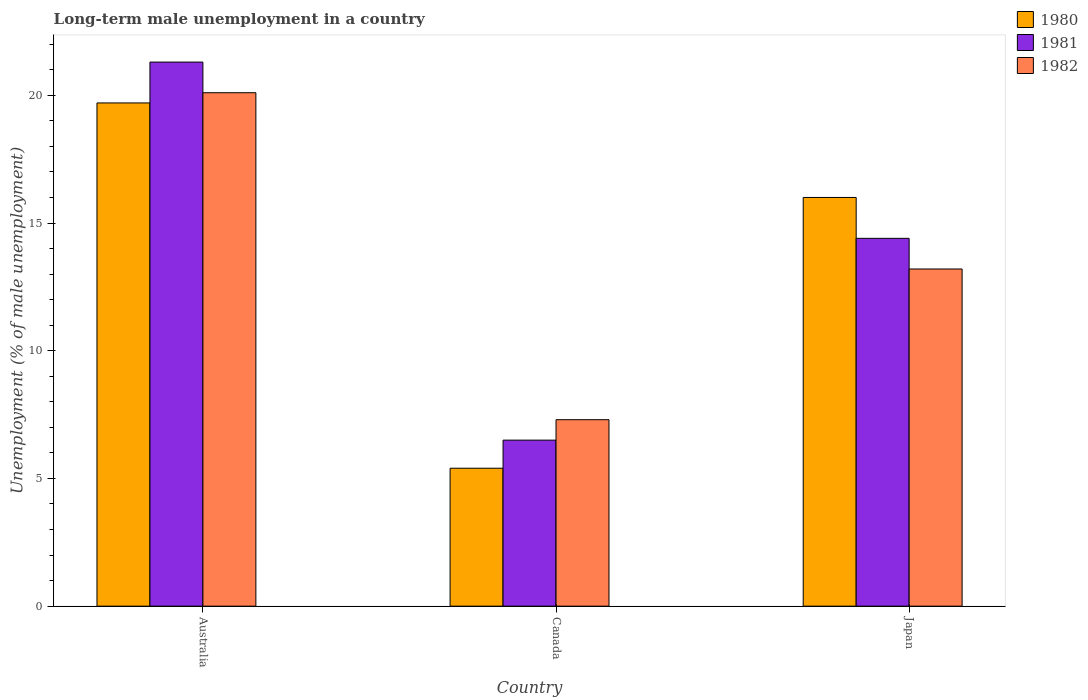How many different coloured bars are there?
Give a very brief answer. 3. Are the number of bars per tick equal to the number of legend labels?
Keep it short and to the point. Yes. How many bars are there on the 1st tick from the left?
Provide a succinct answer. 3. How many bars are there on the 3rd tick from the right?
Keep it short and to the point. 3. What is the percentage of long-term unemployed male population in 1980 in Canada?
Give a very brief answer. 5.4. Across all countries, what is the maximum percentage of long-term unemployed male population in 1981?
Your answer should be compact. 21.3. Across all countries, what is the minimum percentage of long-term unemployed male population in 1980?
Give a very brief answer. 5.4. What is the total percentage of long-term unemployed male population in 1980 in the graph?
Provide a short and direct response. 41.1. What is the difference between the percentage of long-term unemployed male population in 1980 in Canada and that in Japan?
Your answer should be compact. -10.6. What is the difference between the percentage of long-term unemployed male population in 1980 in Australia and the percentage of long-term unemployed male population in 1982 in Canada?
Your response must be concise. 12.4. What is the average percentage of long-term unemployed male population in 1981 per country?
Provide a short and direct response. 14.07. What is the difference between the percentage of long-term unemployed male population of/in 1982 and percentage of long-term unemployed male population of/in 1980 in Australia?
Your response must be concise. 0.4. In how many countries, is the percentage of long-term unemployed male population in 1980 greater than 9 %?
Make the answer very short. 2. What is the ratio of the percentage of long-term unemployed male population in 1982 in Canada to that in Japan?
Provide a short and direct response. 0.55. Is the percentage of long-term unemployed male population in 1980 in Canada less than that in Japan?
Provide a short and direct response. Yes. What is the difference between the highest and the second highest percentage of long-term unemployed male population in 1982?
Your response must be concise. 6.9. What is the difference between the highest and the lowest percentage of long-term unemployed male population in 1980?
Provide a succinct answer. 14.3. Is the sum of the percentage of long-term unemployed male population in 1980 in Australia and Japan greater than the maximum percentage of long-term unemployed male population in 1981 across all countries?
Offer a terse response. Yes. What does the 1st bar from the left in Canada represents?
Offer a terse response. 1980. Is it the case that in every country, the sum of the percentage of long-term unemployed male population in 1981 and percentage of long-term unemployed male population in 1982 is greater than the percentage of long-term unemployed male population in 1980?
Give a very brief answer. Yes. Are all the bars in the graph horizontal?
Keep it short and to the point. No. What is the difference between two consecutive major ticks on the Y-axis?
Provide a short and direct response. 5. Where does the legend appear in the graph?
Ensure brevity in your answer.  Top right. How many legend labels are there?
Give a very brief answer. 3. How are the legend labels stacked?
Your answer should be compact. Vertical. What is the title of the graph?
Your response must be concise. Long-term male unemployment in a country. What is the label or title of the X-axis?
Make the answer very short. Country. What is the label or title of the Y-axis?
Give a very brief answer. Unemployment (% of male unemployment). What is the Unemployment (% of male unemployment) in 1980 in Australia?
Offer a very short reply. 19.7. What is the Unemployment (% of male unemployment) of 1981 in Australia?
Offer a very short reply. 21.3. What is the Unemployment (% of male unemployment) in 1982 in Australia?
Your answer should be very brief. 20.1. What is the Unemployment (% of male unemployment) in 1980 in Canada?
Give a very brief answer. 5.4. What is the Unemployment (% of male unemployment) of 1982 in Canada?
Make the answer very short. 7.3. What is the Unemployment (% of male unemployment) of 1980 in Japan?
Your answer should be very brief. 16. What is the Unemployment (% of male unemployment) of 1981 in Japan?
Offer a terse response. 14.4. What is the Unemployment (% of male unemployment) of 1982 in Japan?
Your answer should be very brief. 13.2. Across all countries, what is the maximum Unemployment (% of male unemployment) of 1980?
Keep it short and to the point. 19.7. Across all countries, what is the maximum Unemployment (% of male unemployment) of 1981?
Provide a short and direct response. 21.3. Across all countries, what is the maximum Unemployment (% of male unemployment) in 1982?
Give a very brief answer. 20.1. Across all countries, what is the minimum Unemployment (% of male unemployment) in 1980?
Provide a short and direct response. 5.4. Across all countries, what is the minimum Unemployment (% of male unemployment) in 1982?
Offer a terse response. 7.3. What is the total Unemployment (% of male unemployment) in 1980 in the graph?
Keep it short and to the point. 41.1. What is the total Unemployment (% of male unemployment) in 1981 in the graph?
Ensure brevity in your answer.  42.2. What is the total Unemployment (% of male unemployment) in 1982 in the graph?
Provide a succinct answer. 40.6. What is the difference between the Unemployment (% of male unemployment) in 1981 in Australia and that in Canada?
Offer a terse response. 14.8. What is the difference between the Unemployment (% of male unemployment) of 1982 in Australia and that in Canada?
Make the answer very short. 12.8. What is the difference between the Unemployment (% of male unemployment) of 1980 in Australia and that in Japan?
Give a very brief answer. 3.7. What is the difference between the Unemployment (% of male unemployment) in 1982 in Australia and that in Japan?
Make the answer very short. 6.9. What is the difference between the Unemployment (% of male unemployment) in 1980 in Canada and that in Japan?
Offer a very short reply. -10.6. What is the difference between the Unemployment (% of male unemployment) of 1981 in Canada and that in Japan?
Provide a succinct answer. -7.9. What is the difference between the Unemployment (% of male unemployment) in 1980 in Australia and the Unemployment (% of male unemployment) in 1981 in Canada?
Make the answer very short. 13.2. What is the difference between the Unemployment (% of male unemployment) in 1981 in Australia and the Unemployment (% of male unemployment) in 1982 in Canada?
Make the answer very short. 14. What is the difference between the Unemployment (% of male unemployment) in 1980 in Australia and the Unemployment (% of male unemployment) in 1982 in Japan?
Give a very brief answer. 6.5. What is the difference between the Unemployment (% of male unemployment) in 1980 in Canada and the Unemployment (% of male unemployment) in 1981 in Japan?
Provide a succinct answer. -9. What is the difference between the Unemployment (% of male unemployment) of 1981 in Canada and the Unemployment (% of male unemployment) of 1982 in Japan?
Make the answer very short. -6.7. What is the average Unemployment (% of male unemployment) of 1981 per country?
Your answer should be compact. 14.07. What is the average Unemployment (% of male unemployment) of 1982 per country?
Your response must be concise. 13.53. What is the difference between the Unemployment (% of male unemployment) of 1980 and Unemployment (% of male unemployment) of 1981 in Australia?
Make the answer very short. -1.6. What is the difference between the Unemployment (% of male unemployment) in 1981 and Unemployment (% of male unemployment) in 1982 in Australia?
Offer a very short reply. 1.2. What is the difference between the Unemployment (% of male unemployment) in 1980 and Unemployment (% of male unemployment) in 1982 in Canada?
Keep it short and to the point. -1.9. What is the difference between the Unemployment (% of male unemployment) of 1980 and Unemployment (% of male unemployment) of 1981 in Japan?
Keep it short and to the point. 1.6. What is the difference between the Unemployment (% of male unemployment) of 1980 and Unemployment (% of male unemployment) of 1982 in Japan?
Offer a very short reply. 2.8. What is the difference between the Unemployment (% of male unemployment) in 1981 and Unemployment (% of male unemployment) in 1982 in Japan?
Your answer should be compact. 1.2. What is the ratio of the Unemployment (% of male unemployment) in 1980 in Australia to that in Canada?
Make the answer very short. 3.65. What is the ratio of the Unemployment (% of male unemployment) in 1981 in Australia to that in Canada?
Keep it short and to the point. 3.28. What is the ratio of the Unemployment (% of male unemployment) in 1982 in Australia to that in Canada?
Make the answer very short. 2.75. What is the ratio of the Unemployment (% of male unemployment) of 1980 in Australia to that in Japan?
Make the answer very short. 1.23. What is the ratio of the Unemployment (% of male unemployment) in 1981 in Australia to that in Japan?
Your answer should be very brief. 1.48. What is the ratio of the Unemployment (% of male unemployment) in 1982 in Australia to that in Japan?
Provide a succinct answer. 1.52. What is the ratio of the Unemployment (% of male unemployment) in 1980 in Canada to that in Japan?
Ensure brevity in your answer.  0.34. What is the ratio of the Unemployment (% of male unemployment) of 1981 in Canada to that in Japan?
Provide a short and direct response. 0.45. What is the ratio of the Unemployment (% of male unemployment) of 1982 in Canada to that in Japan?
Provide a succinct answer. 0.55. What is the difference between the highest and the second highest Unemployment (% of male unemployment) of 1980?
Your answer should be compact. 3.7. What is the difference between the highest and the second highest Unemployment (% of male unemployment) of 1981?
Provide a short and direct response. 6.9. What is the difference between the highest and the lowest Unemployment (% of male unemployment) of 1980?
Offer a very short reply. 14.3. What is the difference between the highest and the lowest Unemployment (% of male unemployment) in 1981?
Ensure brevity in your answer.  14.8. What is the difference between the highest and the lowest Unemployment (% of male unemployment) of 1982?
Ensure brevity in your answer.  12.8. 